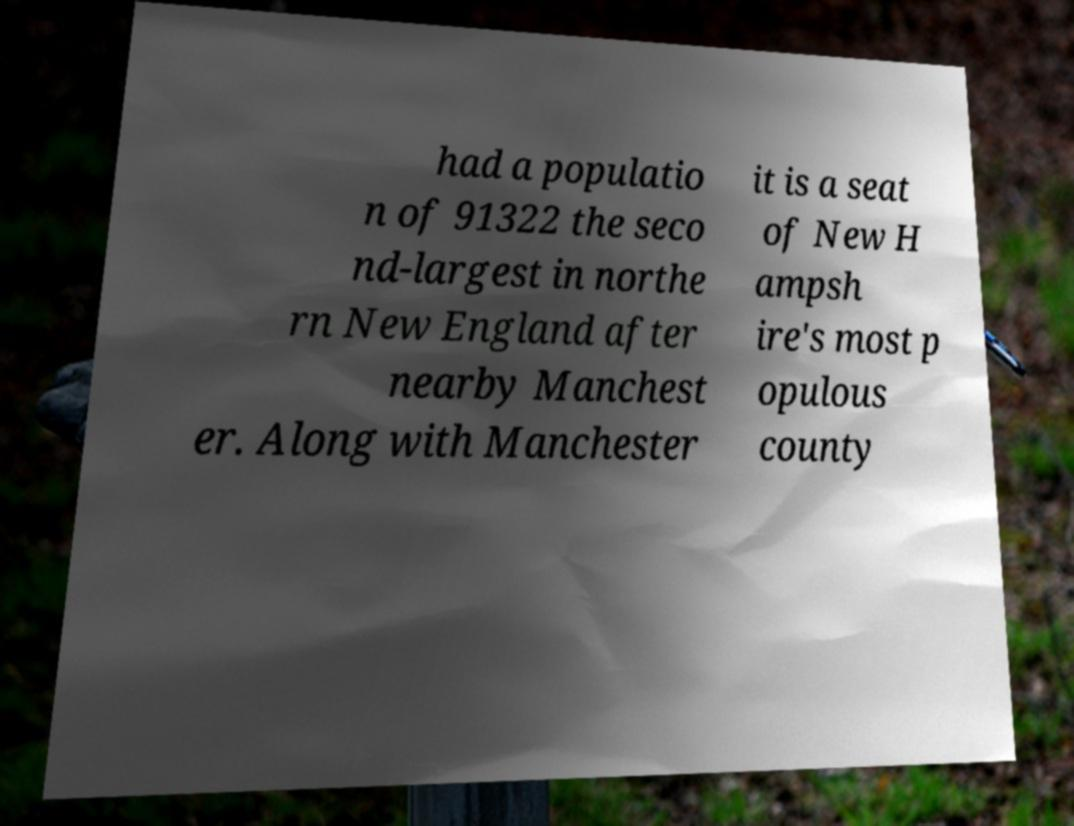I need the written content from this picture converted into text. Can you do that? had a populatio n of 91322 the seco nd-largest in northe rn New England after nearby Manchest er. Along with Manchester it is a seat of New H ampsh ire's most p opulous county 